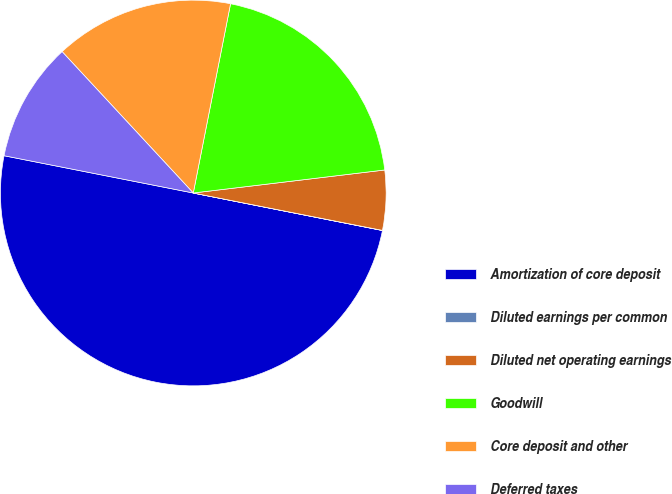Convert chart to OTSL. <chart><loc_0><loc_0><loc_500><loc_500><pie_chart><fcel>Amortization of core deposit<fcel>Diluted earnings per common<fcel>Diluted net operating earnings<fcel>Goodwill<fcel>Core deposit and other<fcel>Deferred taxes<nl><fcel>49.98%<fcel>0.01%<fcel>5.01%<fcel>20.0%<fcel>15.0%<fcel>10.0%<nl></chart> 